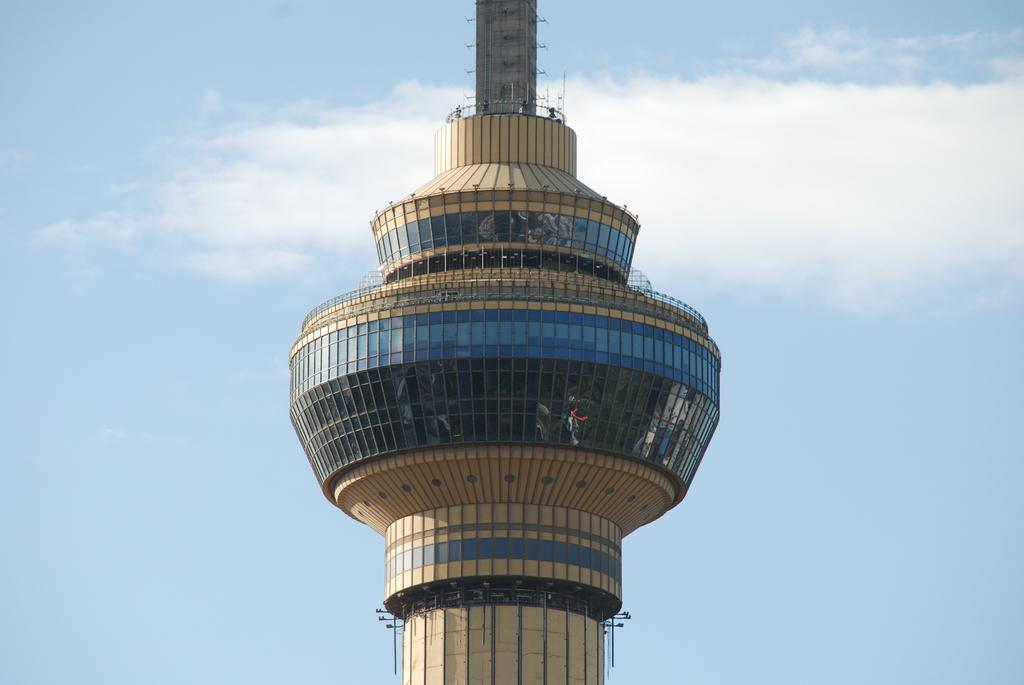What type of structure is in the image? There is a concrete tower in the image. What can be seen illuminated in the image? Lights are visible in the image. What material is present in the image? Glass is present in the image. What type of barrier is in the image? There is fencing in the image. What are the vertical supports in the image? Poles are visible in the image. What is visible in the background of the image? The sky is visible in the background of the image, and clouds are present. What degree of difficulty is the carriage facing in the image? There is no carriage present in the image, so it is not possible to determine the degree of difficulty it might be facing. 